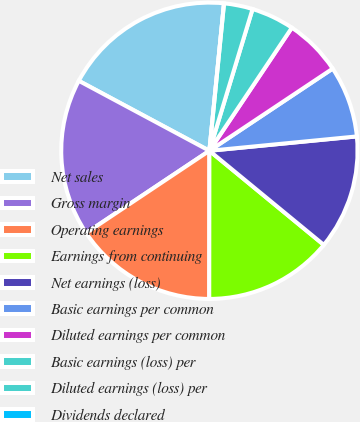Convert chart. <chart><loc_0><loc_0><loc_500><loc_500><pie_chart><fcel>Net sales<fcel>Gross margin<fcel>Operating earnings<fcel>Earnings from continuing<fcel>Net earnings (loss)<fcel>Basic earnings per common<fcel>Diluted earnings per common<fcel>Basic earnings (loss) per<fcel>Diluted earnings (loss) per<fcel>Dividends declared<nl><fcel>18.75%<fcel>17.19%<fcel>15.62%<fcel>14.06%<fcel>12.5%<fcel>7.81%<fcel>6.25%<fcel>4.69%<fcel>3.13%<fcel>0.0%<nl></chart> 